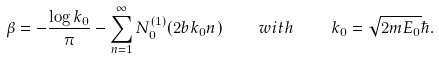<formula> <loc_0><loc_0><loc_500><loc_500>\beta = - \frac { \log k _ { 0 } } { \pi } - \sum _ { n = 1 } ^ { \infty } N _ { 0 } ^ { ( 1 ) } ( 2 b k _ { 0 } n ) \quad w i t h \quad k _ { 0 } = \sqrt { 2 m E _ { 0 } } \hbar { . }</formula> 